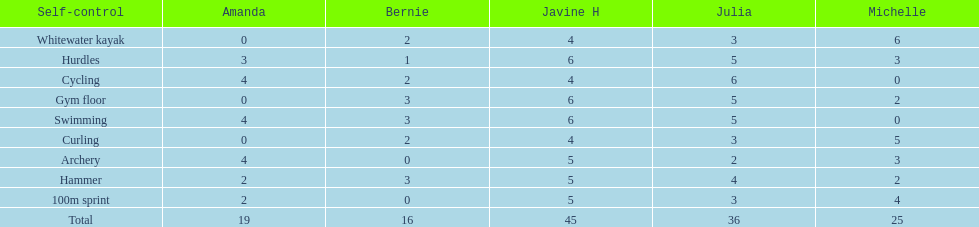What is the first discipline listed on this chart? Whitewater kayak. 